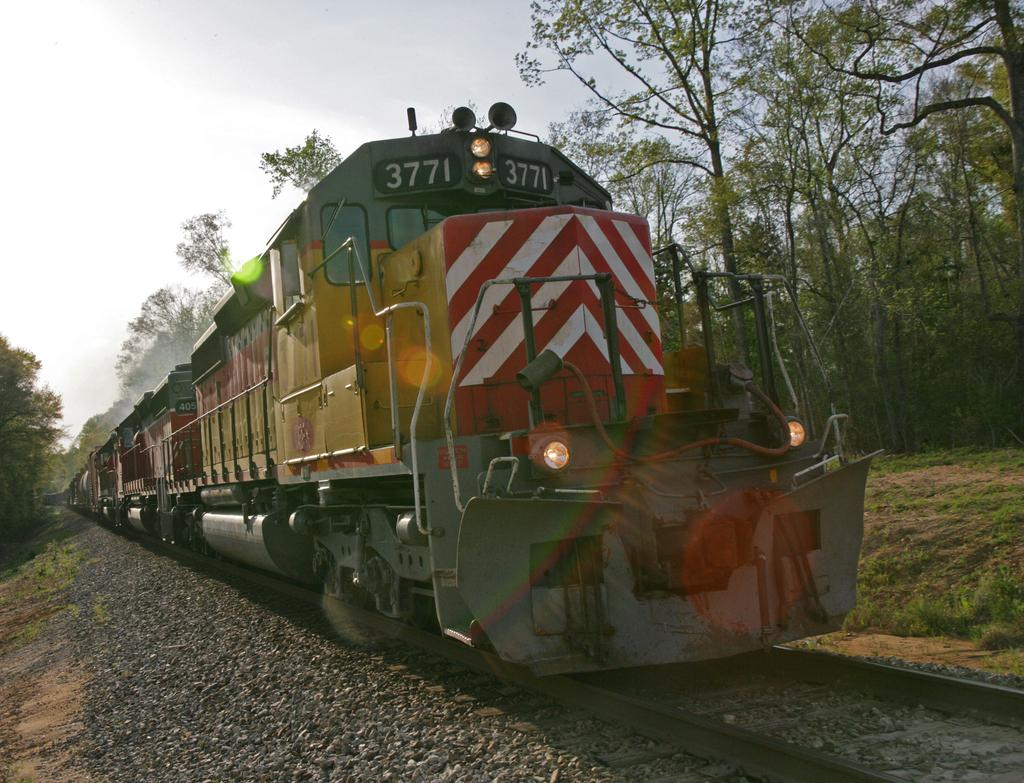What is the main subject of the image? The main subject of the image is a train on the track. What type of vegetation can be seen in the image? There is grass, trees, and plants visible in the image. What other objects can be seen in the image? There are stones in the image. What is visible in the background of the image? The sky is visible in the background of the image. How many kittens are playing with the rat in the aftermath of the train accident in the image? There is no train accident, kittens, or rat present in the image. 